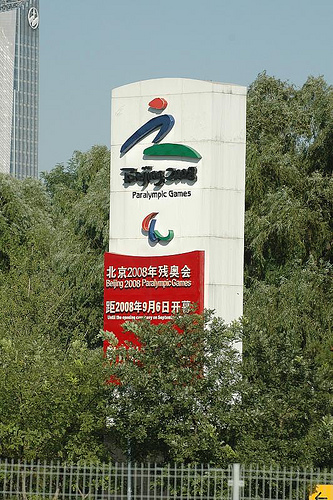<image>
Can you confirm if the sign is behind the trees? No. The sign is not behind the trees. From this viewpoint, the sign appears to be positioned elsewhere in the scene. 